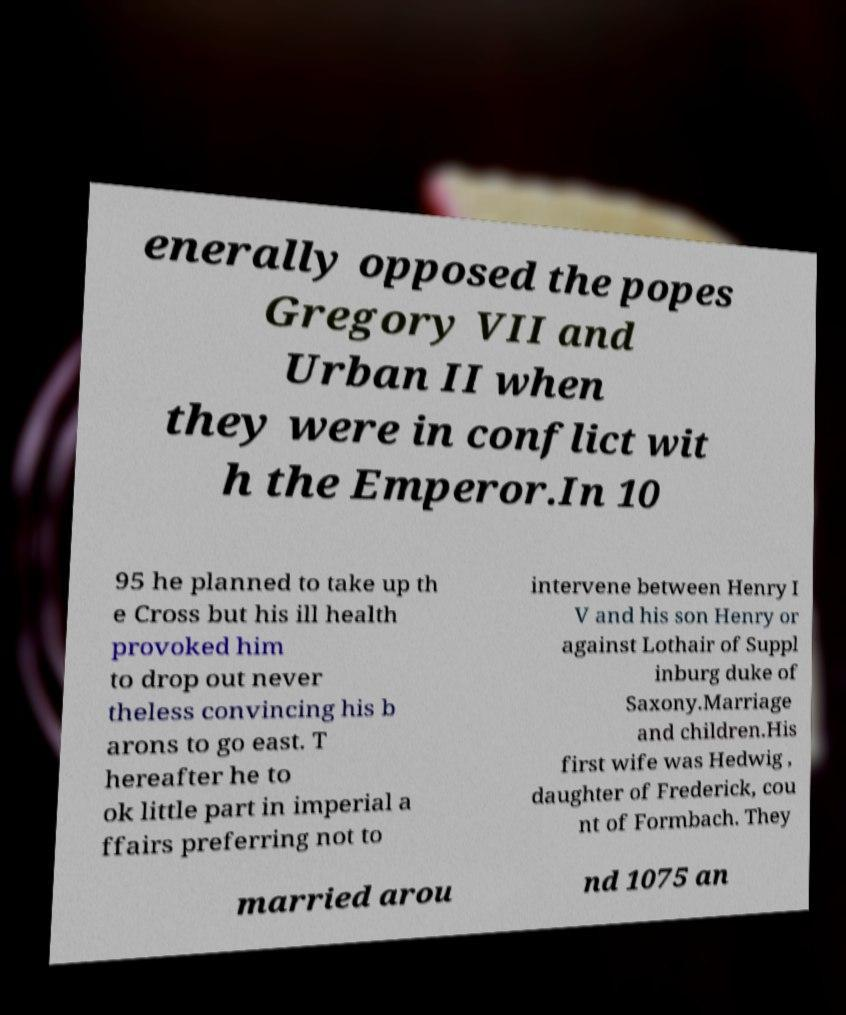Can you read and provide the text displayed in the image?This photo seems to have some interesting text. Can you extract and type it out for me? enerally opposed the popes Gregory VII and Urban II when they were in conflict wit h the Emperor.In 10 95 he planned to take up th e Cross but his ill health provoked him to drop out never theless convincing his b arons to go east. T hereafter he to ok little part in imperial a ffairs preferring not to intervene between Henry I V and his son Henry or against Lothair of Suppl inburg duke of Saxony.Marriage and children.His first wife was Hedwig , daughter of Frederick, cou nt of Formbach. They married arou nd 1075 an 